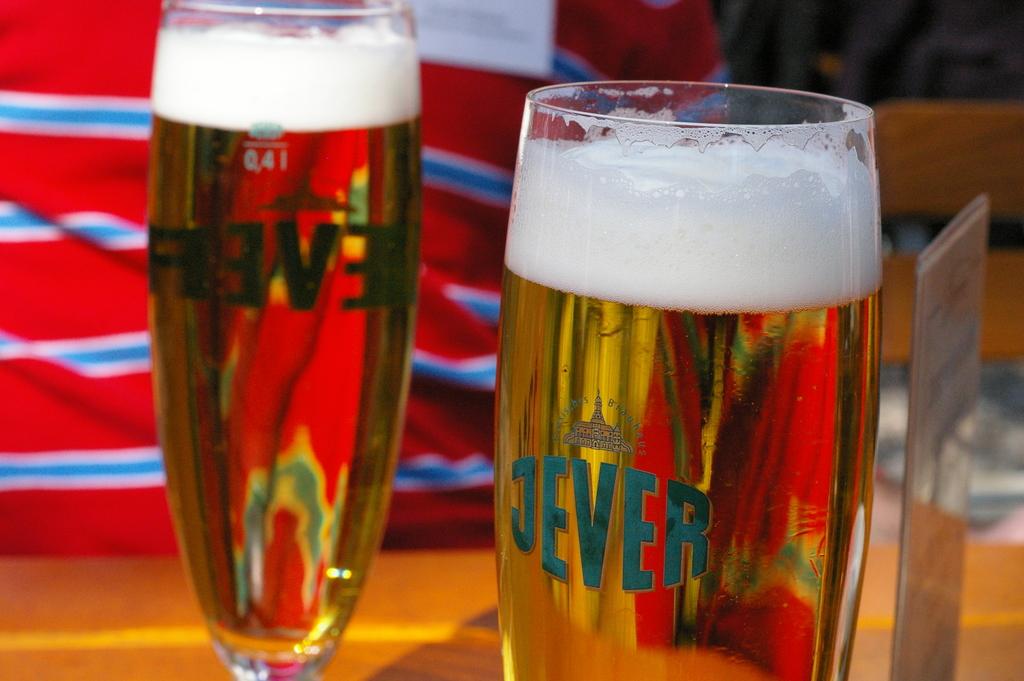What kind of beer are they drinking?
Give a very brief answer. Jever. What number is written on the glass on the left?
Provide a short and direct response. 041. 